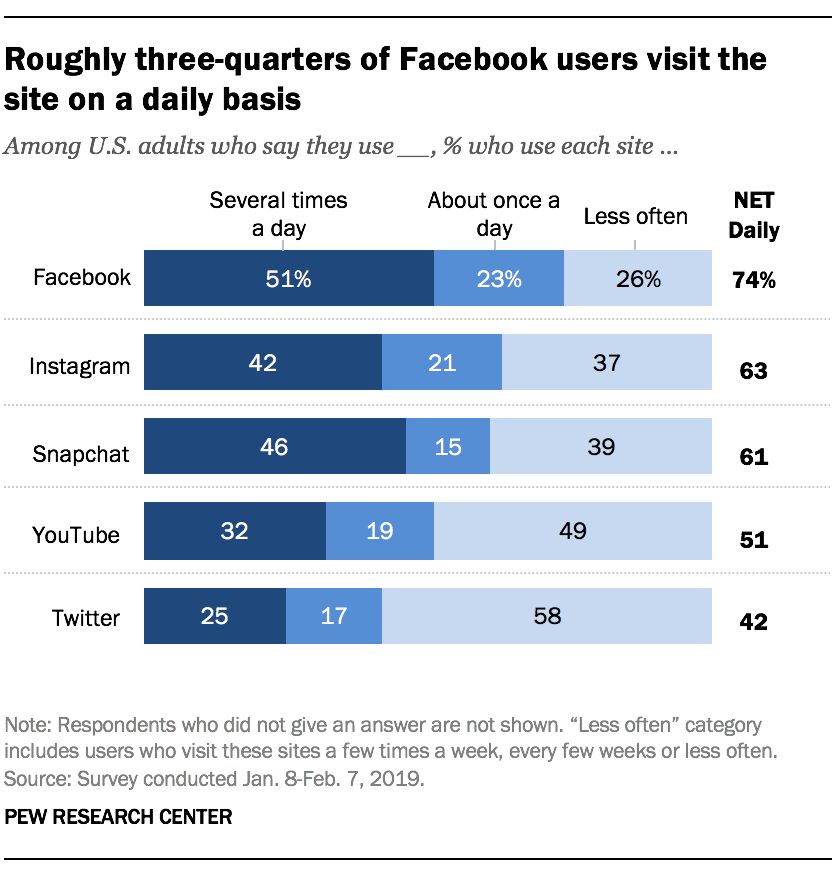Mention a couple of crucial points in this snapshot. The difference in the value of Twitter's highest value and lowest value is 41. The maximum value in the blue bar is 51. 